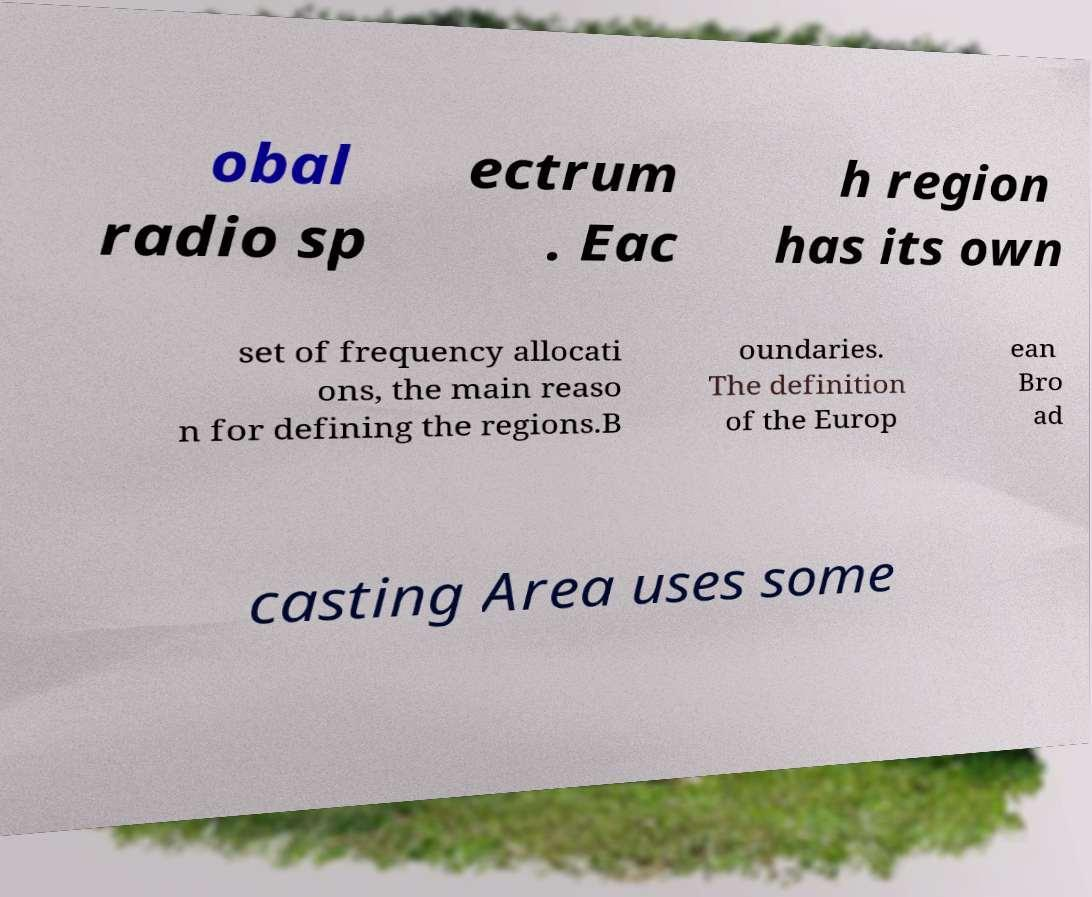Please read and relay the text visible in this image. What does it say? obal radio sp ectrum . Eac h region has its own set of frequency allocati ons, the main reaso n for defining the regions.B oundaries. The definition of the Europ ean Bro ad casting Area uses some 